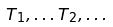Convert formula to latex. <formula><loc_0><loc_0><loc_500><loc_500>T _ { 1 } , \dots T _ { 2 } , \dots</formula> 